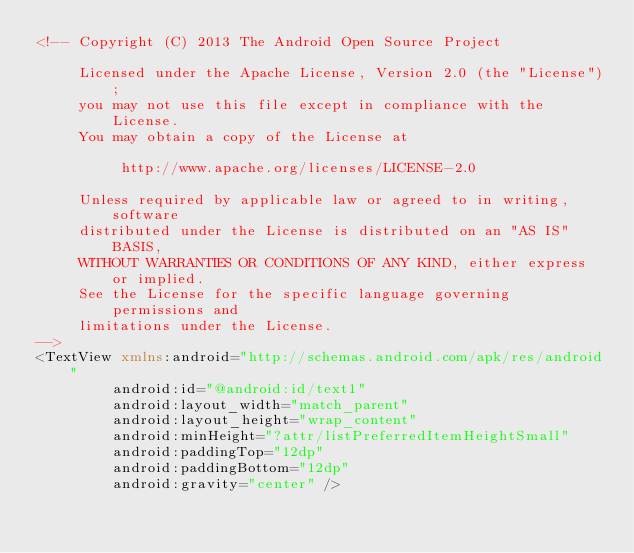Convert code to text. <code><loc_0><loc_0><loc_500><loc_500><_XML_><!-- Copyright (C) 2013 The Android Open Source Project

     Licensed under the Apache License, Version 2.0 (the "License");
     you may not use this file except in compliance with the License.
     You may obtain a copy of the License at

          http://www.apache.org/licenses/LICENSE-2.0

     Unless required by applicable law or agreed to in writing, software
     distributed under the License is distributed on an "AS IS" BASIS,
     WITHOUT WARRANTIES OR CONDITIONS OF ANY KIND, either express or implied.
     See the License for the specific language governing permissions and
     limitations under the License.
-->
<TextView xmlns:android="http://schemas.android.com/apk/res/android"
         android:id="@android:id/text1"
         android:layout_width="match_parent"
         android:layout_height="wrap_content"
         android:minHeight="?attr/listPreferredItemHeightSmall"
         android:paddingTop="12dp"
         android:paddingBottom="12dp"
         android:gravity="center" />
</code> 